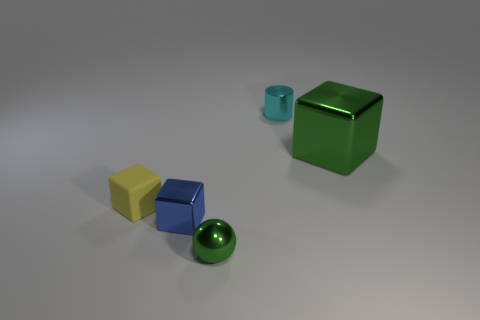How many metal things have the same color as the large metallic cube?
Make the answer very short. 1. There is a green object on the right side of the tiny object behind the metallic block right of the green sphere; what is it made of?
Give a very brief answer. Metal. There is a object in front of the tiny blue metal cube; is its color the same as the thing that is to the right of the shiny cylinder?
Give a very brief answer. Yes. What is the cube right of the small object on the right side of the metallic ball made of?
Keep it short and to the point. Metal. There is a matte object that is the same size as the blue metal object; what color is it?
Ensure brevity in your answer.  Yellow. Is the shape of the cyan object the same as the object that is on the right side of the tiny metal cylinder?
Offer a terse response. No. The large metal thing that is the same color as the sphere is what shape?
Your answer should be very brief. Cube. How many matte things are behind the metal block that is in front of the green metal object behind the tiny yellow object?
Provide a succinct answer. 1. There is a metallic block on the right side of the shiny block left of the cyan thing; how big is it?
Your answer should be very brief. Large. What size is the green thing that is the same material as the sphere?
Ensure brevity in your answer.  Large. 